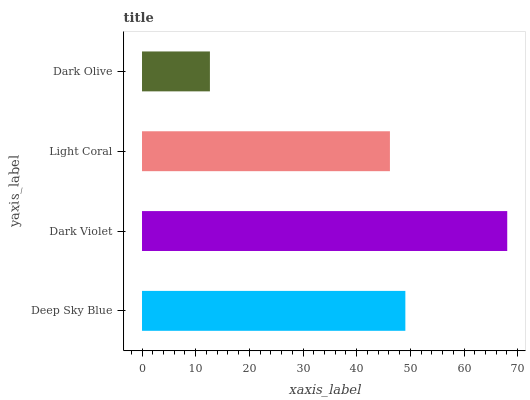Is Dark Olive the minimum?
Answer yes or no. Yes. Is Dark Violet the maximum?
Answer yes or no. Yes. Is Light Coral the minimum?
Answer yes or no. No. Is Light Coral the maximum?
Answer yes or no. No. Is Dark Violet greater than Light Coral?
Answer yes or no. Yes. Is Light Coral less than Dark Violet?
Answer yes or no. Yes. Is Light Coral greater than Dark Violet?
Answer yes or no. No. Is Dark Violet less than Light Coral?
Answer yes or no. No. Is Deep Sky Blue the high median?
Answer yes or no. Yes. Is Light Coral the low median?
Answer yes or no. Yes. Is Light Coral the high median?
Answer yes or no. No. Is Dark Olive the low median?
Answer yes or no. No. 